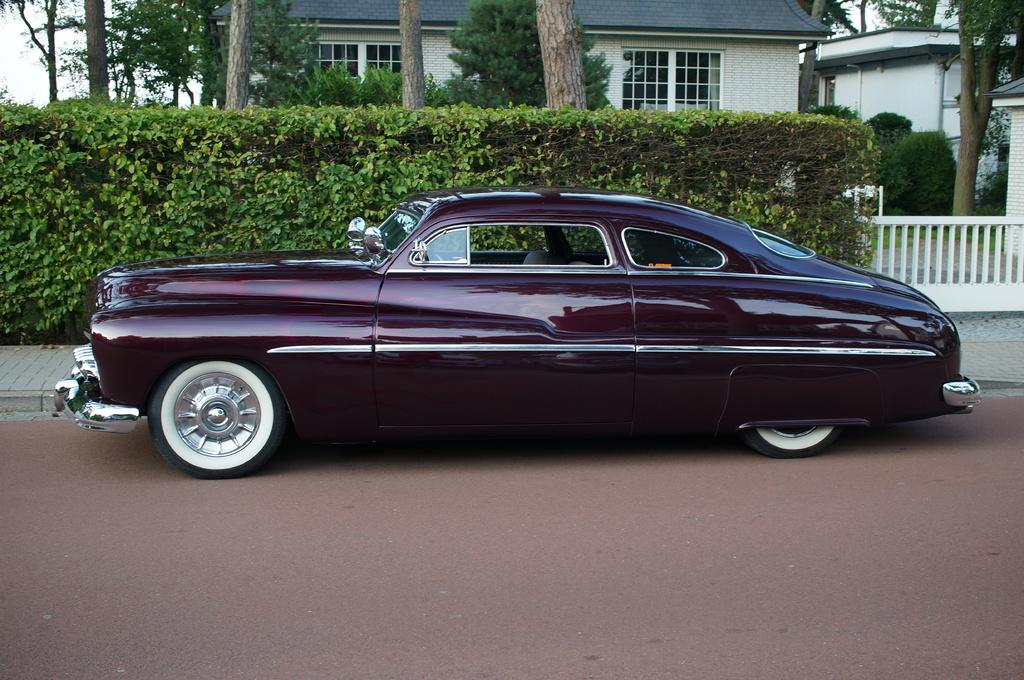What is on the road in the image? There is a vehicle on the road in the image. What structures can be seen in the image? There are buildings in the image. What type of vegetation is present in the image? Plants and trees are visible in the image. What architectural features can be observed in the image? There are windows and grills present in the image. What is visible in the background of the image? The sky is visible in the background of the image. Can you tell me how many cubs are playing with icicles in the image? There are no cubs or icicles present in the image. What type of wheel is visible on the vehicle in the image? The image does not show the type of wheel on the vehicle; it only shows the vehicle on the road. 